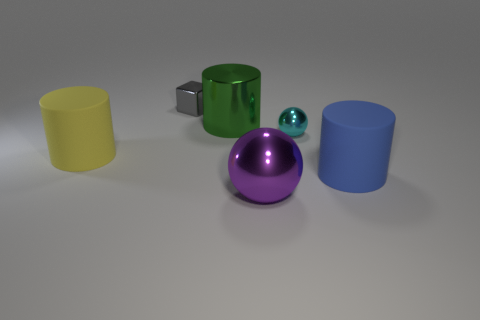There is a big blue cylinder to the right of the big object that is behind the small metal thing on the right side of the tiny gray block; what is it made of?
Your response must be concise. Rubber. What shape is the metal object that is the same size as the gray cube?
Ensure brevity in your answer.  Sphere. Are there fewer big green shiny things than tiny blue objects?
Provide a short and direct response. No. How many blue matte cylinders are the same size as the yellow object?
Your answer should be very brief. 1. What is the material of the large blue thing?
Your response must be concise. Rubber. What size is the rubber cylinder in front of the yellow matte object?
Offer a terse response. Large. How many green metallic objects are the same shape as the blue object?
Offer a very short reply. 1. There is a yellow thing that is made of the same material as the big blue thing; what is its shape?
Offer a very short reply. Cylinder. What number of cyan objects are tiny metal spheres or spheres?
Your answer should be very brief. 1. There is a big green metal thing; are there any big green metal objects to the right of it?
Your answer should be compact. No. 